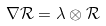Convert formula to latex. <formula><loc_0><loc_0><loc_500><loc_500>\nabla \mathcal { R } = \lambda \otimes \mathcal { R }</formula> 